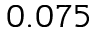<formula> <loc_0><loc_0><loc_500><loc_500>0 . 0 7 5</formula> 